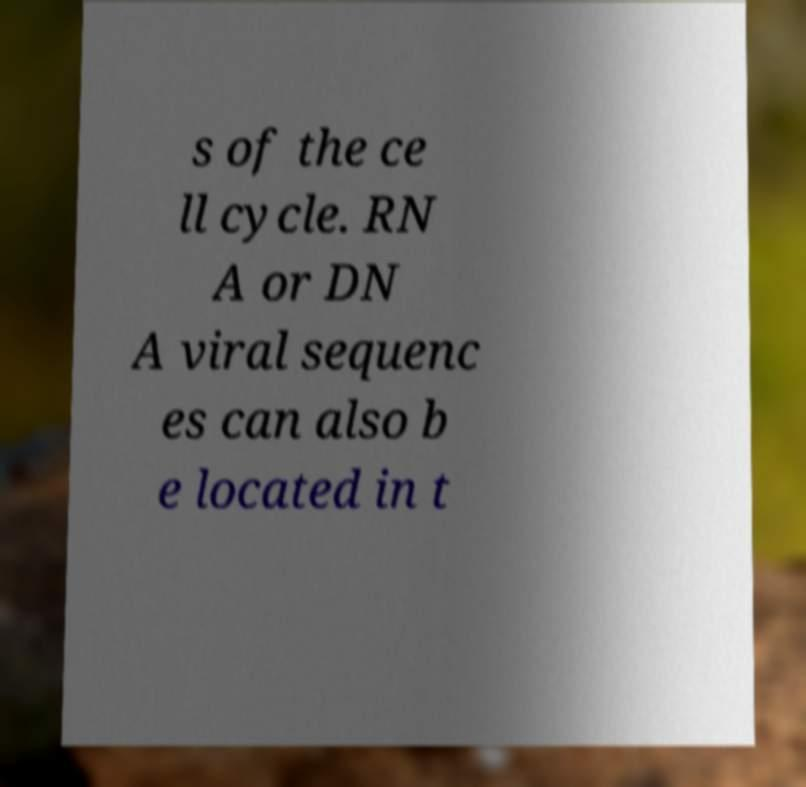What messages or text are displayed in this image? I need them in a readable, typed format. s of the ce ll cycle. RN A or DN A viral sequenc es can also b e located in t 